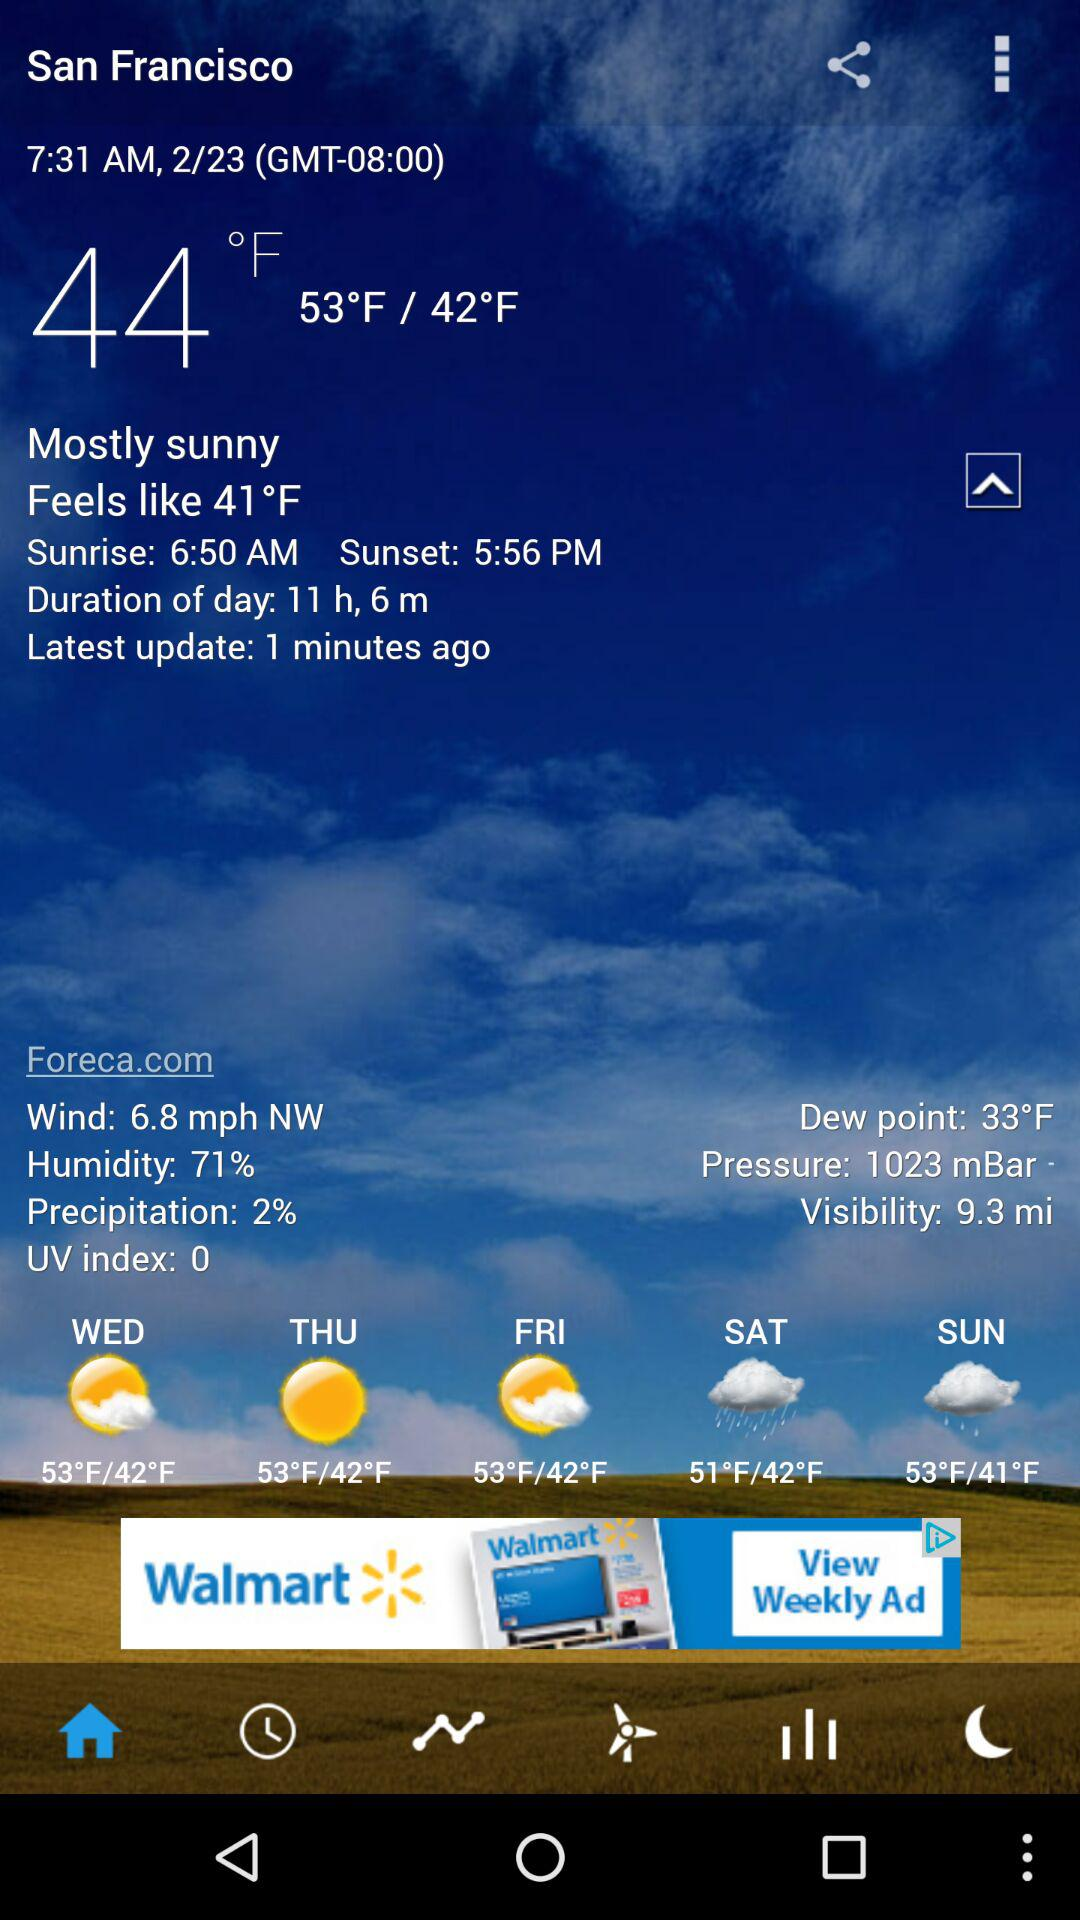What time does the sun rise? The sun rises at 6:50 AM. 